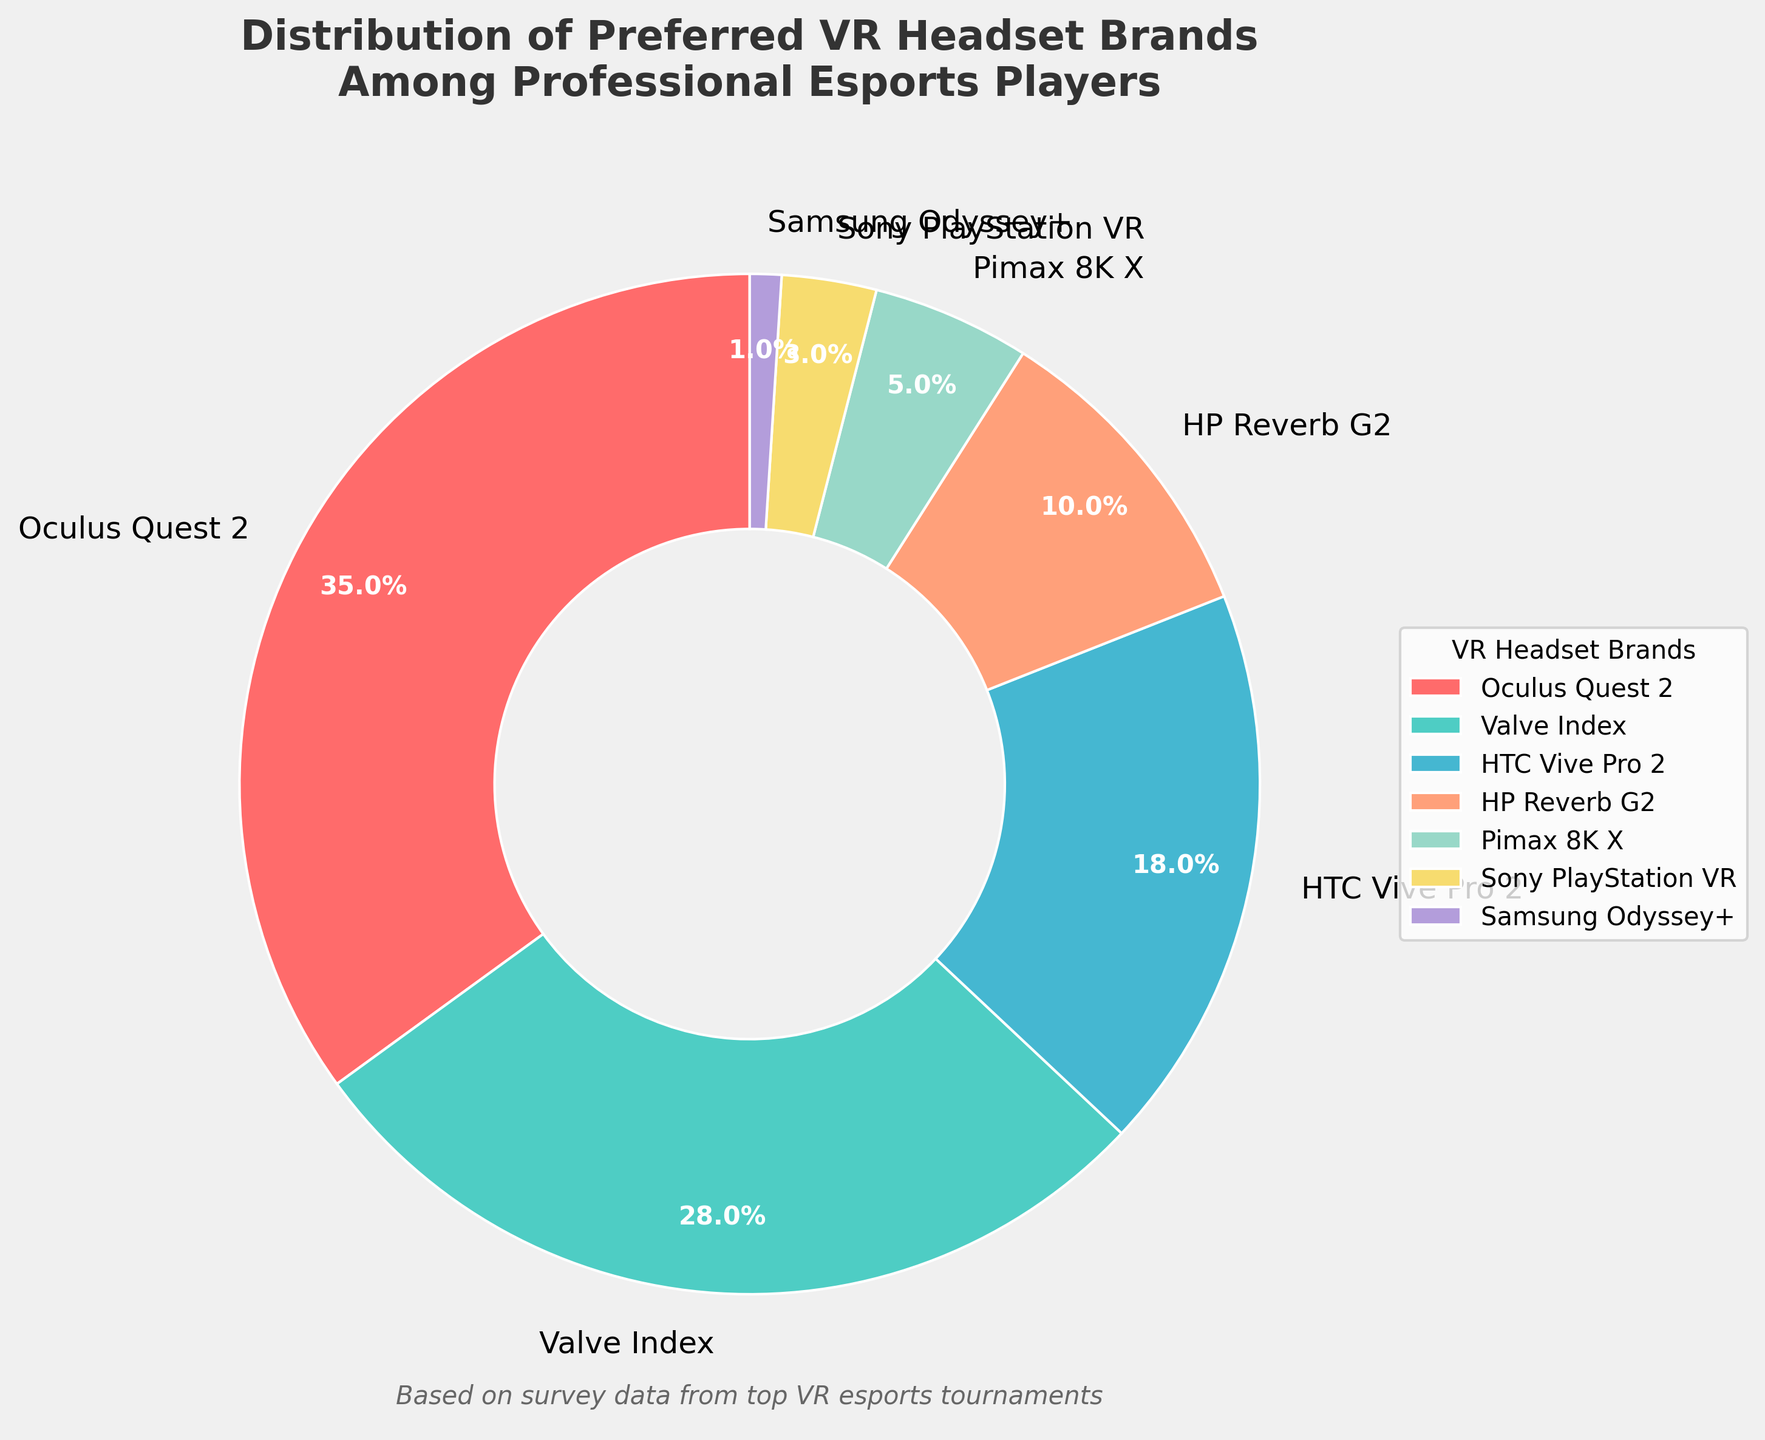Which brand has the highest preference among professional esports players? Oculus Quest 2 has the highest percentage among all brands at 35%. The percentage is directly noted on the slice labeled "Oculus Quest 2" which represents the largest portion of the pie chart.
Answer: Oculus Quest 2 What's the difference in preference between Valve Index and HTC Vive Pro 2? The preference for Valve Index is 28% while for HTC Vive Pro 2 it is 18%. The difference can be calculated by subtracting 18 from 28, which equals 10.
Answer: 10% Summing the preferences for the two least favored brands, what percentage do they account for? The two least favored brands are Samsung Odyssey+ at 1% and Sony PlayStation VR at 3%. Adding these percentages together gives 1% + 3%, which equals 4%.
Answer: 4% Which brand's preference is closer to 20%, and what is its exact value? The brand closest to 20% is HTC Vive Pro 2 with a preference of 18%. This can be observed visually and numerically as the HTC Vive Pro 2 slice closely aligns with the 20% mark compared to other slices.
Answer: HTC Vive Pro 2, 18% How does the preference for HP Reverb G2 compare to Pimax 8K X? HP Reverb G2 has a preference of 10% while Pimax 8K X has 5%. HP Reverb G2's preference is twice as large as Pimax 8K X’s preference.
Answer: HP Reverb G2 is twice Pimax 8K X If we combine the preferences for Valve Index, HTC Vive Pro 2, and HP Reverb G2, what is their combined percentage? Adding the preferences for Valve Index (28%), HTC Vive Pro 2 (18%), and HP Reverb G2 (10%) yields a combined total of 28% + 18% + 10% = 56%.
Answer: 56% Which color represents the Oculus Quest 2 in the pie chart? Oculus Quest 2 is represented by the red segment of the pie chart, which is visually identifiable due to the label and coloration.
Answer: Red Which brands account for less than 10% of the preferences, and what are their individual values? The brands accounting for less than 10% are HP Reverb G2 (10%), Pimax 8K X (5%), Sony PlayStation VR (3%), and Samsung Odyssey+ (1%). HPRG2 is exactly at the borderline, but the other three are well below.
Answer: Pimax 8K X: 5%, Sony PS VR: 3%, Samsung Odyssey+: 1% What is the total percentage of preference for brands other than Oculus Quest 2? The total preference for brands other than Oculus Quest 2 is calculated by subtracting the Oculus Quest 2 percentage (35%) from 100%. Thus, 100% - 35% = 65%.
Answer: 65% 